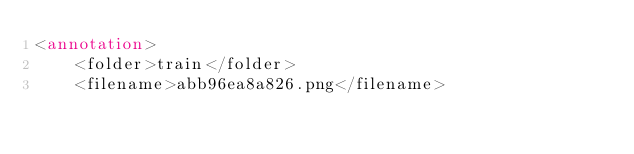Convert code to text. <code><loc_0><loc_0><loc_500><loc_500><_XML_><annotation>
	<folder>train</folder>
	<filename>abb96ea8a826.png</filename></code> 